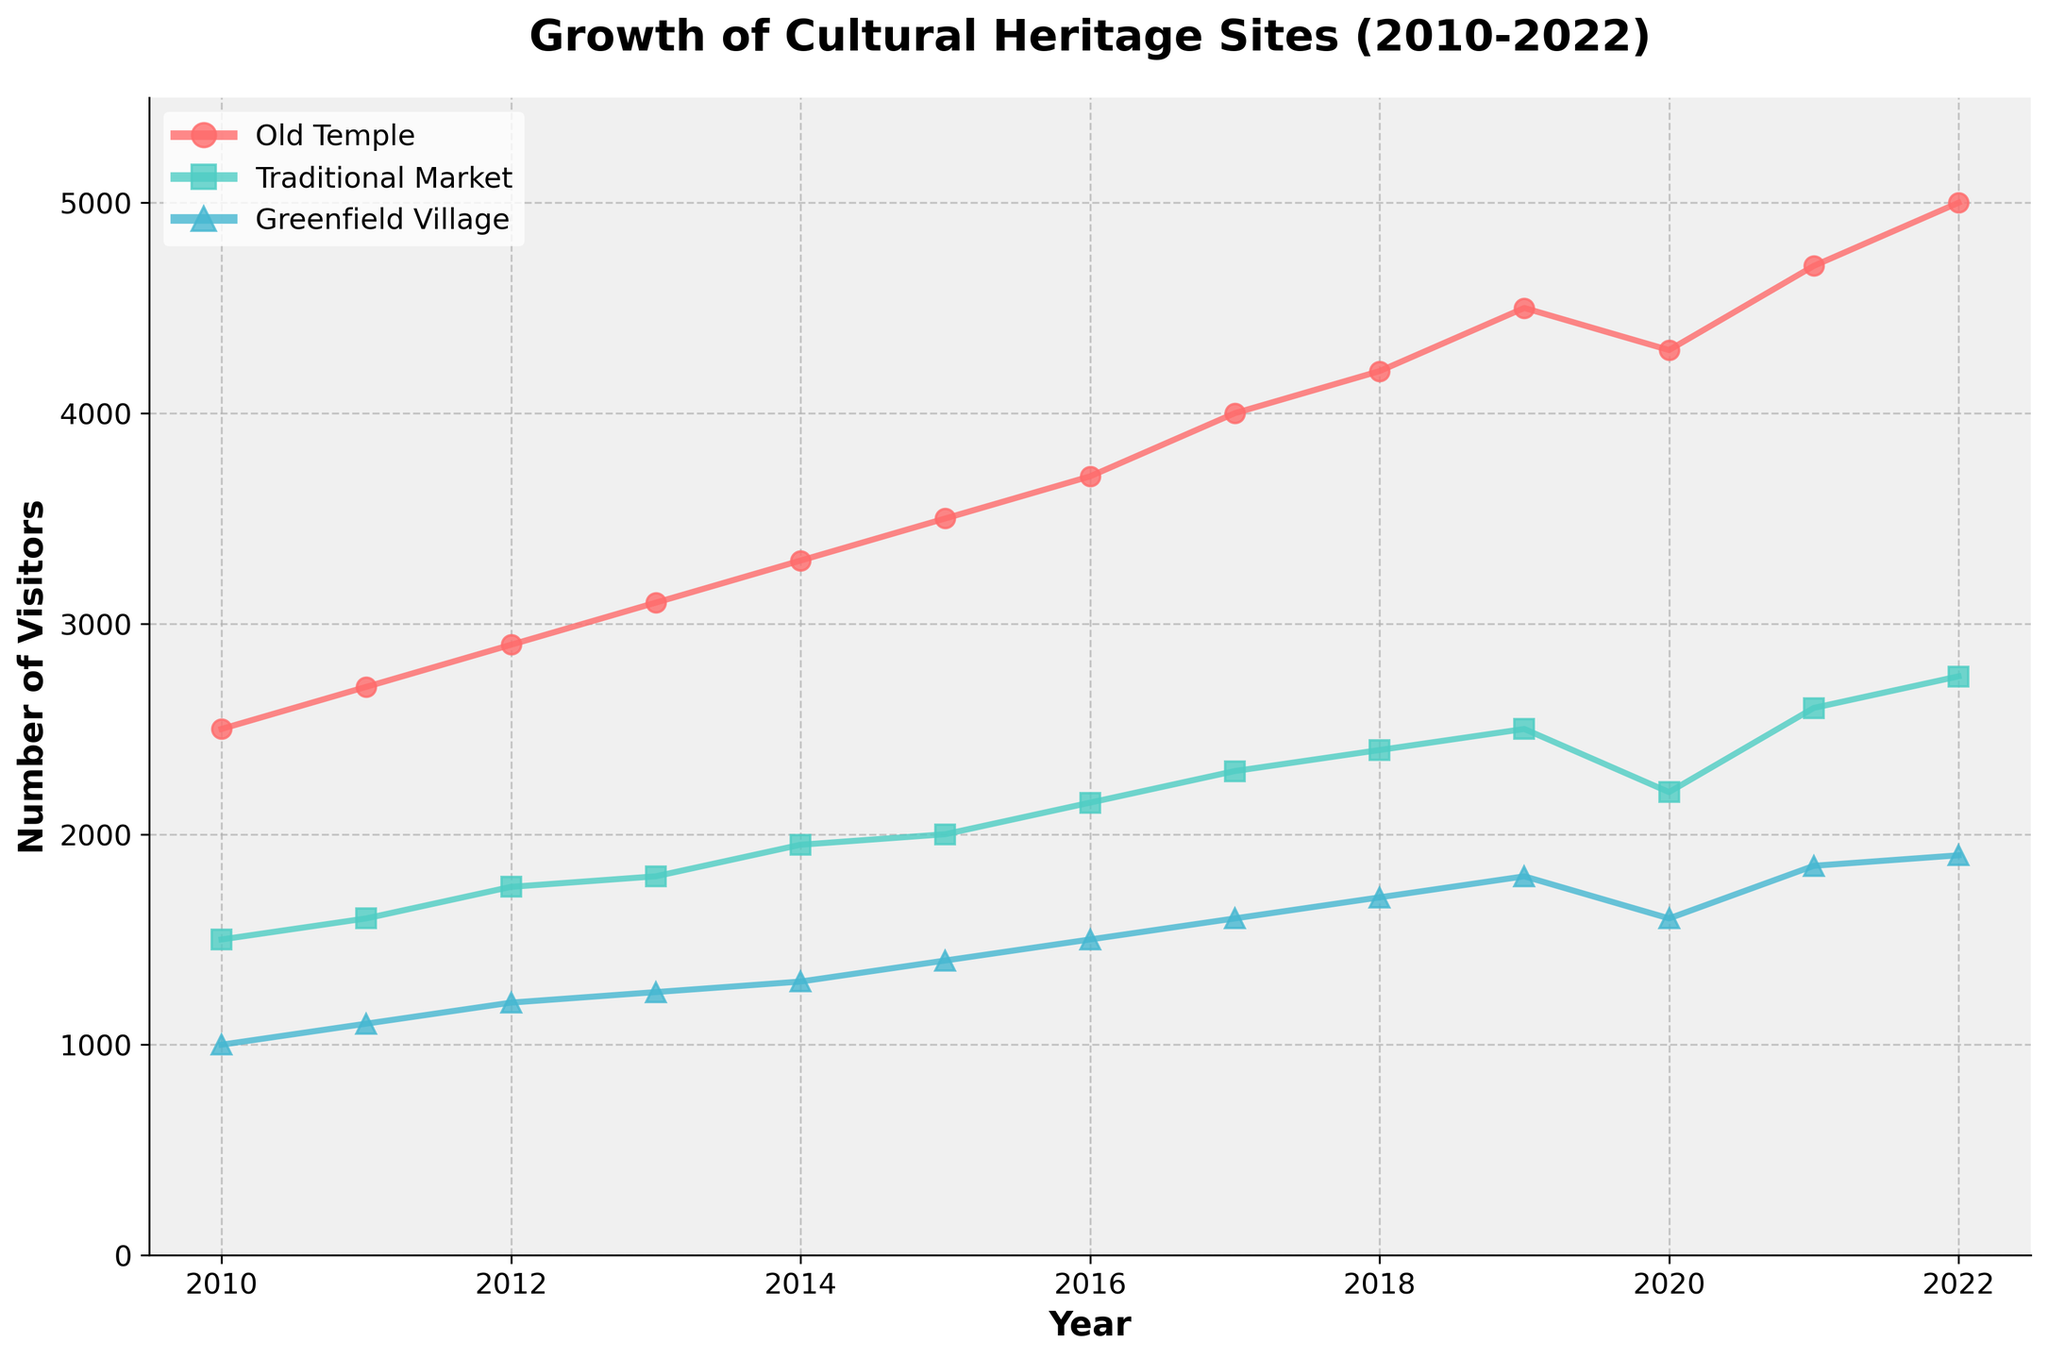What is the title of the figure? The title of the figure is written at the top.
Answer: Growth of Cultural Heritage Sites (2010-2022) Which heritage site had the highest number of visitors in 2010? Look at the data points for 2010 and compare visitor numbers across the heritage sites.
Answer: Old Temple In which year did the Greenfield Village first surpass 1500 visitors? Check the plot where Greenfield Village visitors data crosses the 1500 mark.
Answer: 2017 By how many visitors did the Traditional Market grow from 2010 to 2015? Subtract the number of visitors in 2010 from the number of visitors in 2015. 2000 (2015) - 1500 (2010) = 500
Answer: 500 Which year showed a drop in the number of visitors for all three heritage sites? Identify the year where each site's visitor count decreased compared to the previous year.
Answer: 2020 What is the average number of visitors for the Old Temple across all the years? Add up all the visitors for the Old Temple from 2010 to 2022 and divide by the number of years (13). (2500 + 2700 + 2900 + 3100 + 3300 + 3500 + 3700 + 4000 + 4200 + 4500 + 4300 + 4700 + 5000) / 13 = 3700
Answer: 3700 Compare the number of visitors between Greenfield Village and Traditional Market in 2018. Subtract Greenfield Village visitors from Traditional Market visitors in 2018. 2400 (Traditional Market) - 1700 (Greenfield Village) = 700
Answer: 700 What was the overall trend in visitor numbers for Old Temple from 2010 to 2022? Examine the direction of the data points for Old Temple over the given years.
Answer: Increasing By what percentage did the number of visitors to the Old Temple increase from 2010 to 2022? ((5000 - 2500) / 2500) * 100% = 100%
Answer: 100% Which heritage site had the most consistent growth in visitor numbers over the years? Examine the slopes of the lines for each heritage site and see which one grows consistently without sudden drops or spikes.
Answer: Old Temple 